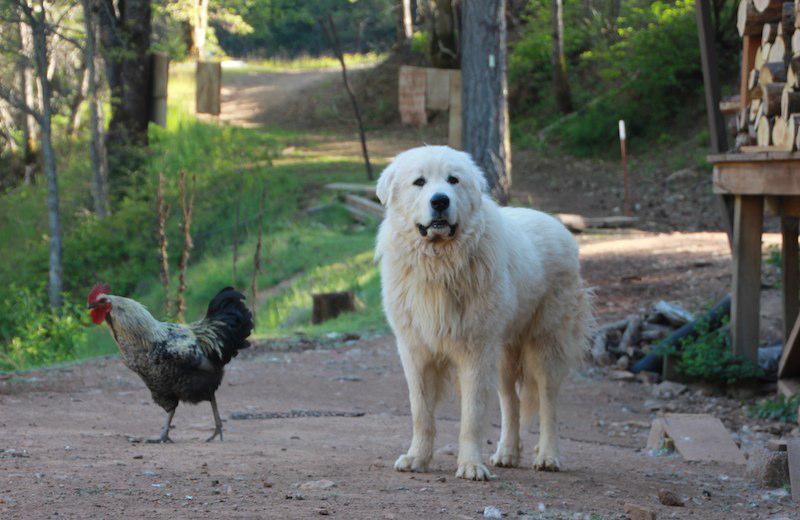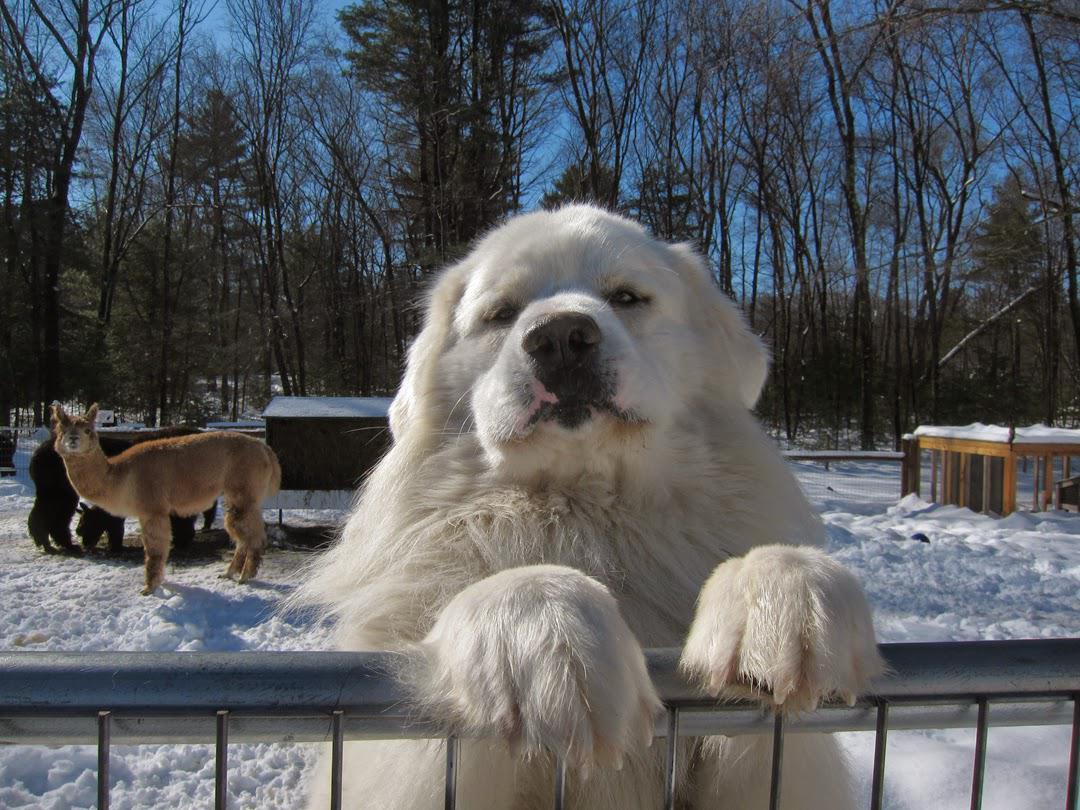The first image is the image on the left, the second image is the image on the right. For the images displayed, is the sentence "At least one white dog is in a scene with goats, and a fence is present in each image." factually correct? Answer yes or no. No. 